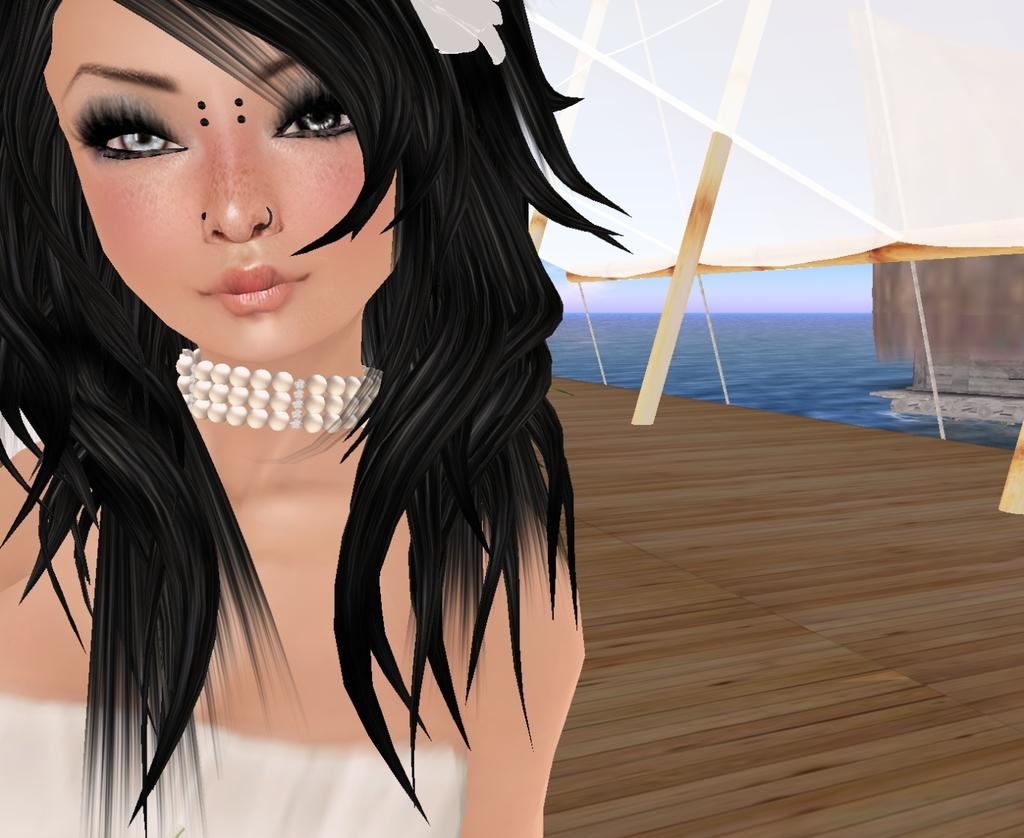What is the main subject of the painting? The painting depicts a lady person. What is the lady person wearing? The lady person is wearing a white dress and a necklace. What type of floor is the lady person standing on? The lady person is standing on a wooden floor. What can be seen in the background of the painting? There is water visible in the background, and the sky is clear. How many dogs are present in the painting? There are no dogs present in the painting; it features a lady person standing on a wooden floor with water and a clear sky in the background. Who is the expert on the painting's subject matter? The provided facts do not mention any expert on the painting's subject matter, so it cannot be determined from the information given. 